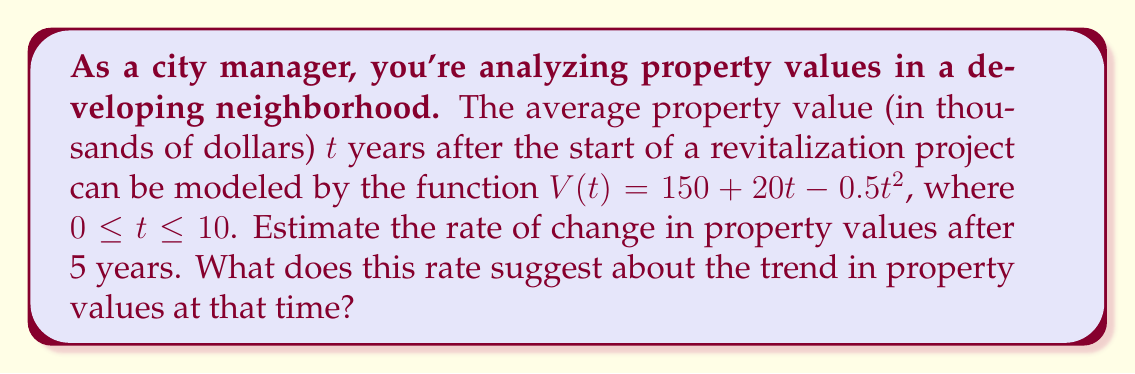Help me with this question. To estimate the rate of change in property values after 5 years, we need to find the derivative of the given function and evaluate it at $t = 5$. Let's proceed step-by-step:

1) The given function is $V(t) = 150 + 20t - 0.5t^2$

2) To find the rate of change, we need to calculate $V'(t)$:
   $$V'(t) = \frac{d}{dt}(150 + 20t - 0.5t^2)$$
   $$V'(t) = 0 + 20 - 0.5(2t)$$
   $$V'(t) = 20 - t$$

3) Now, we evaluate $V'(t)$ at $t = 5$:
   $$V'(5) = 20 - 5 = 15$$

4) Interpretation: The rate of change after 5 years is 15 thousand dollars per year.

5) To understand the trend:
   - A positive rate of change indicates that property values are still increasing.
   - However, since the original function is quadratic with a negative coefficient for $t^2$, the rate of change is decreasing over time (the second derivative is negative).
   - This suggests that while property values are still rising after 5 years, the rate of increase is slowing down.

As a careful and conservative city manager, you should note that while the trend is still positive, the slowing rate of increase might indicate a need for additional measures to maintain property value growth in the future.
Answer: $15$ thousand dollars per year; property values are still increasing but at a decreasing rate. 